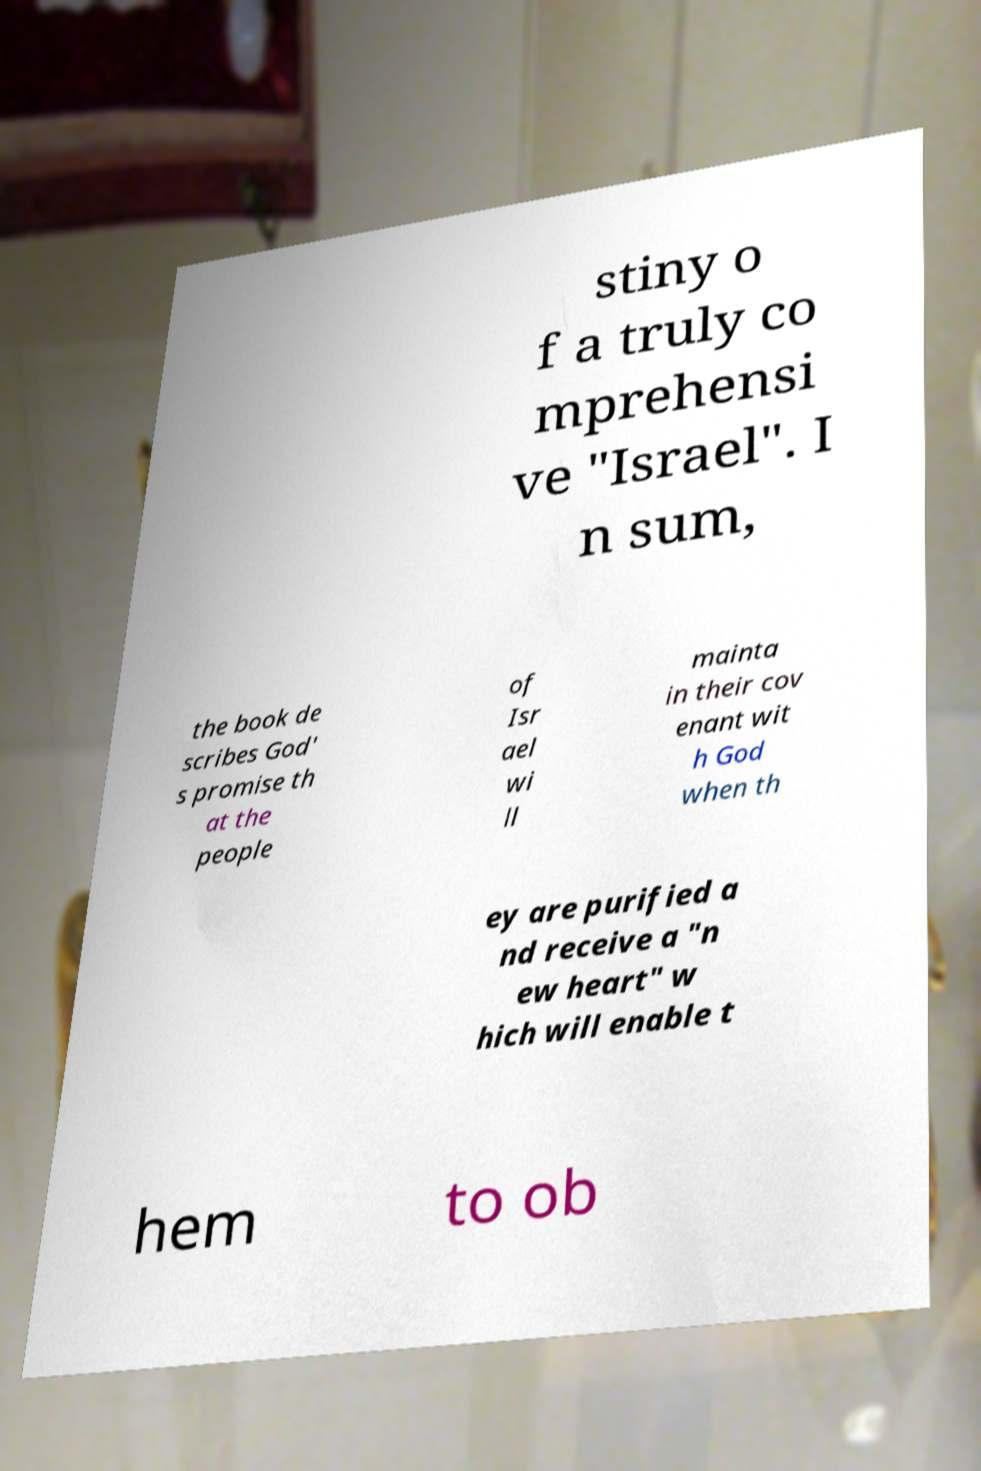Please read and relay the text visible in this image. What does it say? stiny o f a truly co mprehensi ve "Israel". I n sum, the book de scribes God' s promise th at the people of Isr ael wi ll mainta in their cov enant wit h God when th ey are purified a nd receive a "n ew heart" w hich will enable t hem to ob 